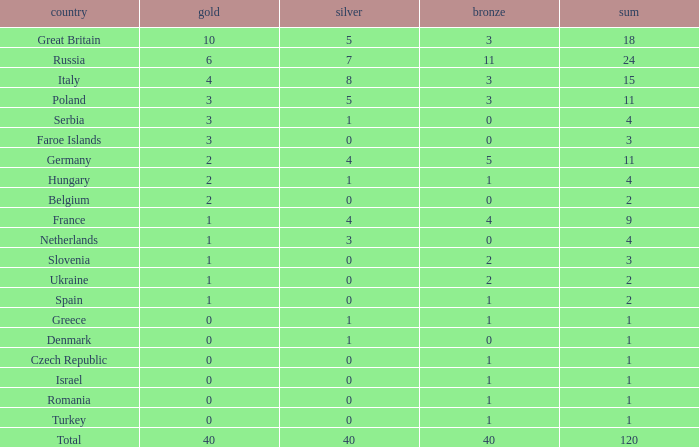What is Turkey's average Gold entry that also has a Bronze entry that is smaller than 2 and the Total is greater than 1? None. Parse the full table. {'header': ['country', 'gold', 'silver', 'bronze', 'sum'], 'rows': [['Great Britain', '10', '5', '3', '18'], ['Russia', '6', '7', '11', '24'], ['Italy', '4', '8', '3', '15'], ['Poland', '3', '5', '3', '11'], ['Serbia', '3', '1', '0', '4'], ['Faroe Islands', '3', '0', '0', '3'], ['Germany', '2', '4', '5', '11'], ['Hungary', '2', '1', '1', '4'], ['Belgium', '2', '0', '0', '2'], ['France', '1', '4', '4', '9'], ['Netherlands', '1', '3', '0', '4'], ['Slovenia', '1', '0', '2', '3'], ['Ukraine', '1', '0', '2', '2'], ['Spain', '1', '0', '1', '2'], ['Greece', '0', '1', '1', '1'], ['Denmark', '0', '1', '0', '1'], ['Czech Republic', '0', '0', '1', '1'], ['Israel', '0', '0', '1', '1'], ['Romania', '0', '0', '1', '1'], ['Turkey', '0', '0', '1', '1'], ['Total', '40', '40', '40', '120']]} 